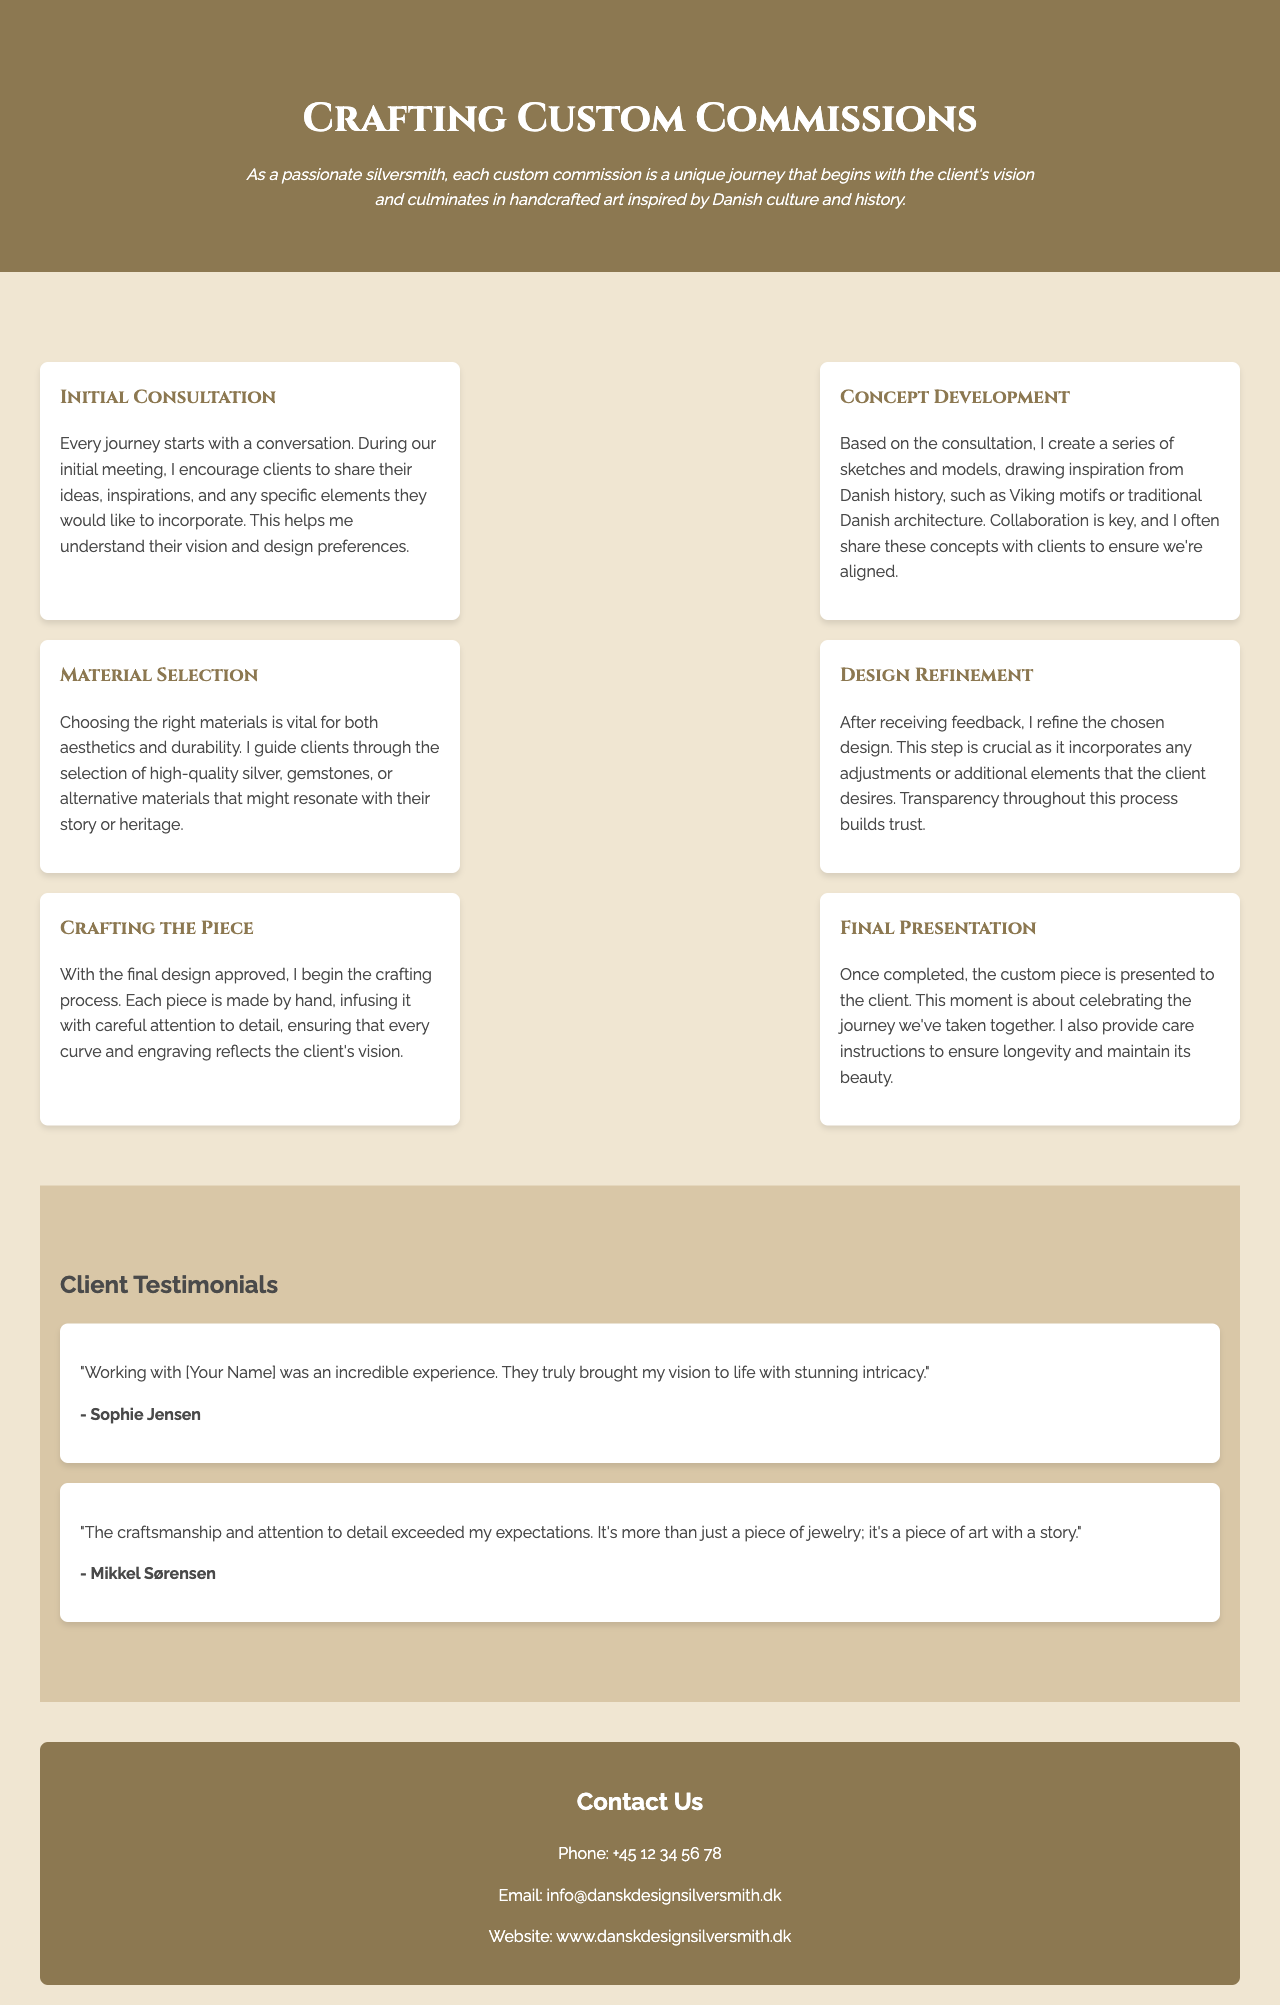What is the title of the brochure? The title of the brochure is displayed prominently at the top of the document, which is "Crafting Custom Commissions: A Journey through the Design Process with Clients."
Answer: Crafting Custom Commissions: A Journey through the Design Process with Clients What is the initial step in the design process? The brochure outlines the design process in steps, with the first step being "Initial Consultation."
Answer: Initial Consultation What is one inspiration source mentioned for concept development? The document includes information about drawing inspiration from Danish history, specifically mentioning Viking motifs or traditional Danish architecture during concept development.
Answer: Viking motifs How many testimonials are included in the brochure? The brochure features a section dedicated to client testimonials and lists two testimonials within that section.
Answer: 2 What is the phone number provided for contact? The contact information section lists a phone number to reach out, which is "+45 12 34 56 78."
Answer: +45 12 34 56 78 During which step is material selection discussed? The step involving the selection of materials is mentioned as "Material Selection," which is a specific part of the overall process.
Answer: Material Selection What element is provided along with the final presentation of the piece? The final presentation of the custom piece includes care instructions to ensure longevity and maintain its beauty as an additional element.
Answer: Care instructions What background color is used in the testimonials section? The testimonials section has a distinct background color specified as "#d9c7a7," which creates a visually appealing contrast.
Answer: #d9c7a7 